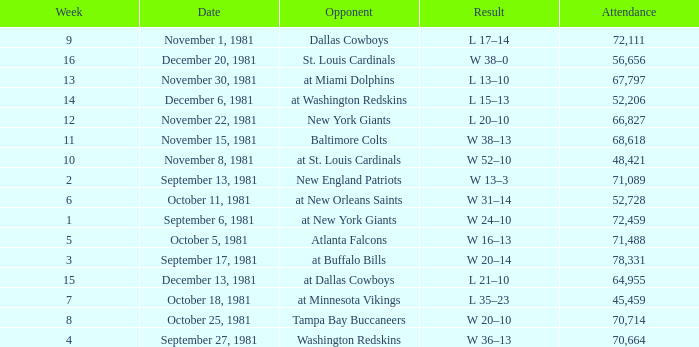Would you be able to parse every entry in this table? {'header': ['Week', 'Date', 'Opponent', 'Result', 'Attendance'], 'rows': [['9', 'November 1, 1981', 'Dallas Cowboys', 'L 17–14', '72,111'], ['16', 'December 20, 1981', 'St. Louis Cardinals', 'W 38–0', '56,656'], ['13', 'November 30, 1981', 'at Miami Dolphins', 'L 13–10', '67,797'], ['14', 'December 6, 1981', 'at Washington Redskins', 'L 15–13', '52,206'], ['12', 'November 22, 1981', 'New York Giants', 'L 20–10', '66,827'], ['11', 'November 15, 1981', 'Baltimore Colts', 'W 38–13', '68,618'], ['10', 'November 8, 1981', 'at St. Louis Cardinals', 'W 52–10', '48,421'], ['2', 'September 13, 1981', 'New England Patriots', 'W 13–3', '71,089'], ['6', 'October 11, 1981', 'at New Orleans Saints', 'W 31–14', '52,728'], ['1', 'September 6, 1981', 'at New York Giants', 'W 24–10', '72,459'], ['5', 'October 5, 1981', 'Atlanta Falcons', 'W 16–13', '71,488'], ['3', 'September 17, 1981', 'at Buffalo Bills', 'W 20–14', '78,331'], ['15', 'December 13, 1981', 'at Dallas Cowboys', 'L 21–10', '64,955'], ['7', 'October 18, 1981', 'at Minnesota Vikings', 'L 35–23', '45,459'], ['8', 'October 25, 1981', 'Tampa Bay Buccaneers', 'W 20–10', '70,714'], ['4', 'September 27, 1981', 'Washington Redskins', 'W 36–13', '70,664']]} What is the average Attendance, when the Date is September 17, 1981? 78331.0. 